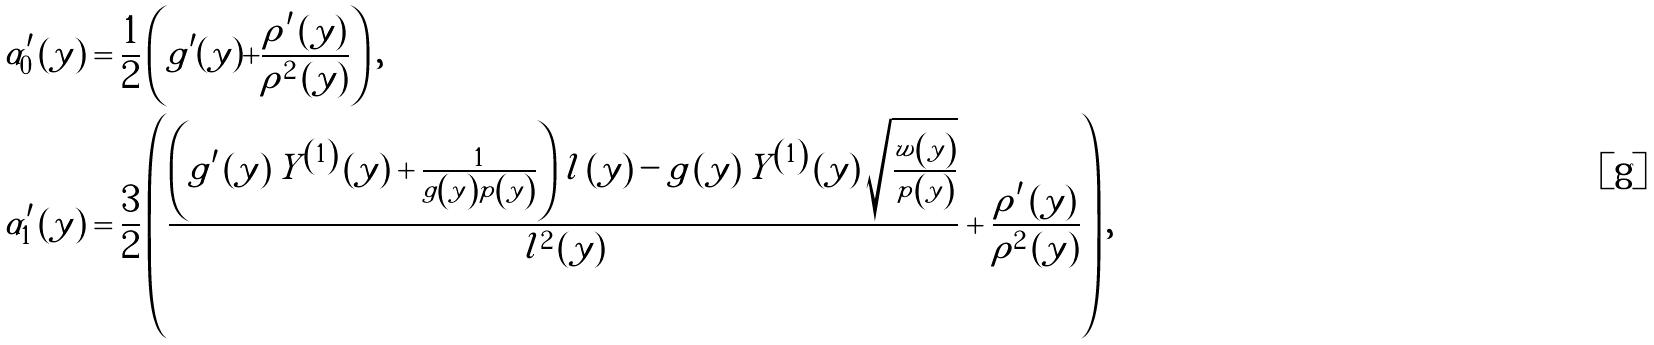<formula> <loc_0><loc_0><loc_500><loc_500>\alpha _ { 0 } ^ { \prime } \left ( y \right ) & = \frac { 1 } { 2 } \left ( g ^ { \prime } ( y ) + \frac { \rho ^ { \prime } \left ( y \right ) } { \rho ^ { 2 } \left ( y \right ) } \right ) , \\ \alpha _ { 1 } ^ { \prime } \left ( y \right ) & = \frac { 3 } { 2 } \left ( \frac { \left ( g ^ { \prime } \left ( y \right ) Y ^ { \left ( 1 \right ) } \left ( y \right ) + \frac { 1 } { g \left ( y \right ) p \left ( y \right ) } \right ) l \left ( y \right ) - g \left ( y \right ) Y ^ { \left ( 1 \right ) } \left ( y \right ) \sqrt { \frac { w \left ( y \right ) } { p \left ( y \right ) } } } { l ^ { 2 } \left ( y \right ) } + \frac { \rho ^ { \prime } \left ( y \right ) } { \rho ^ { 2 } \left ( y \right ) } \right ) ,</formula> 